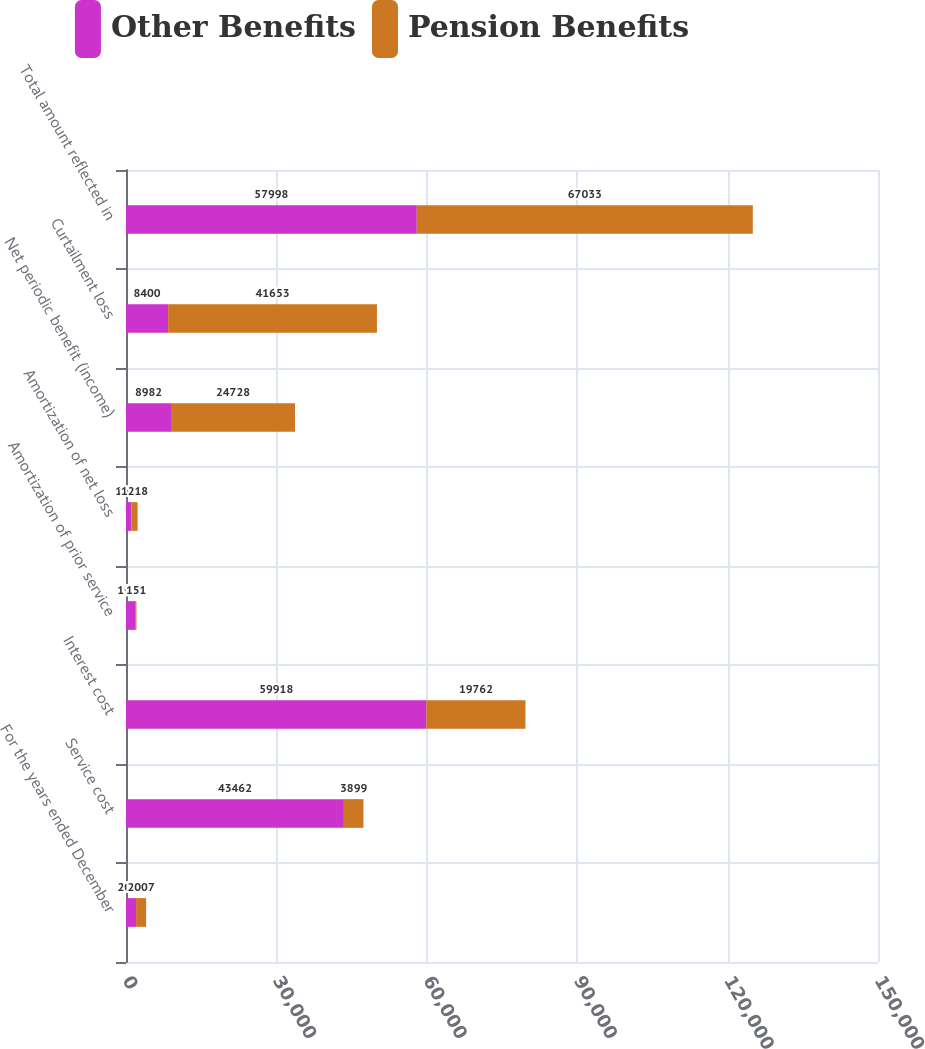Convert chart to OTSL. <chart><loc_0><loc_0><loc_500><loc_500><stacked_bar_chart><ecel><fcel>For the years ended December<fcel>Service cost<fcel>Interest cost<fcel>Amortization of prior service<fcel>Amortization of net loss<fcel>Net periodic benefit (income)<fcel>Curtailment loss<fcel>Total amount reflected in<nl><fcel>Other Benefits<fcel>2007<fcel>43462<fcel>59918<fcel>1936<fcel>1095<fcel>8982<fcel>8400<fcel>57998<nl><fcel>Pension Benefits<fcel>2007<fcel>3899<fcel>19762<fcel>151<fcel>1218<fcel>24728<fcel>41653<fcel>67033<nl></chart> 